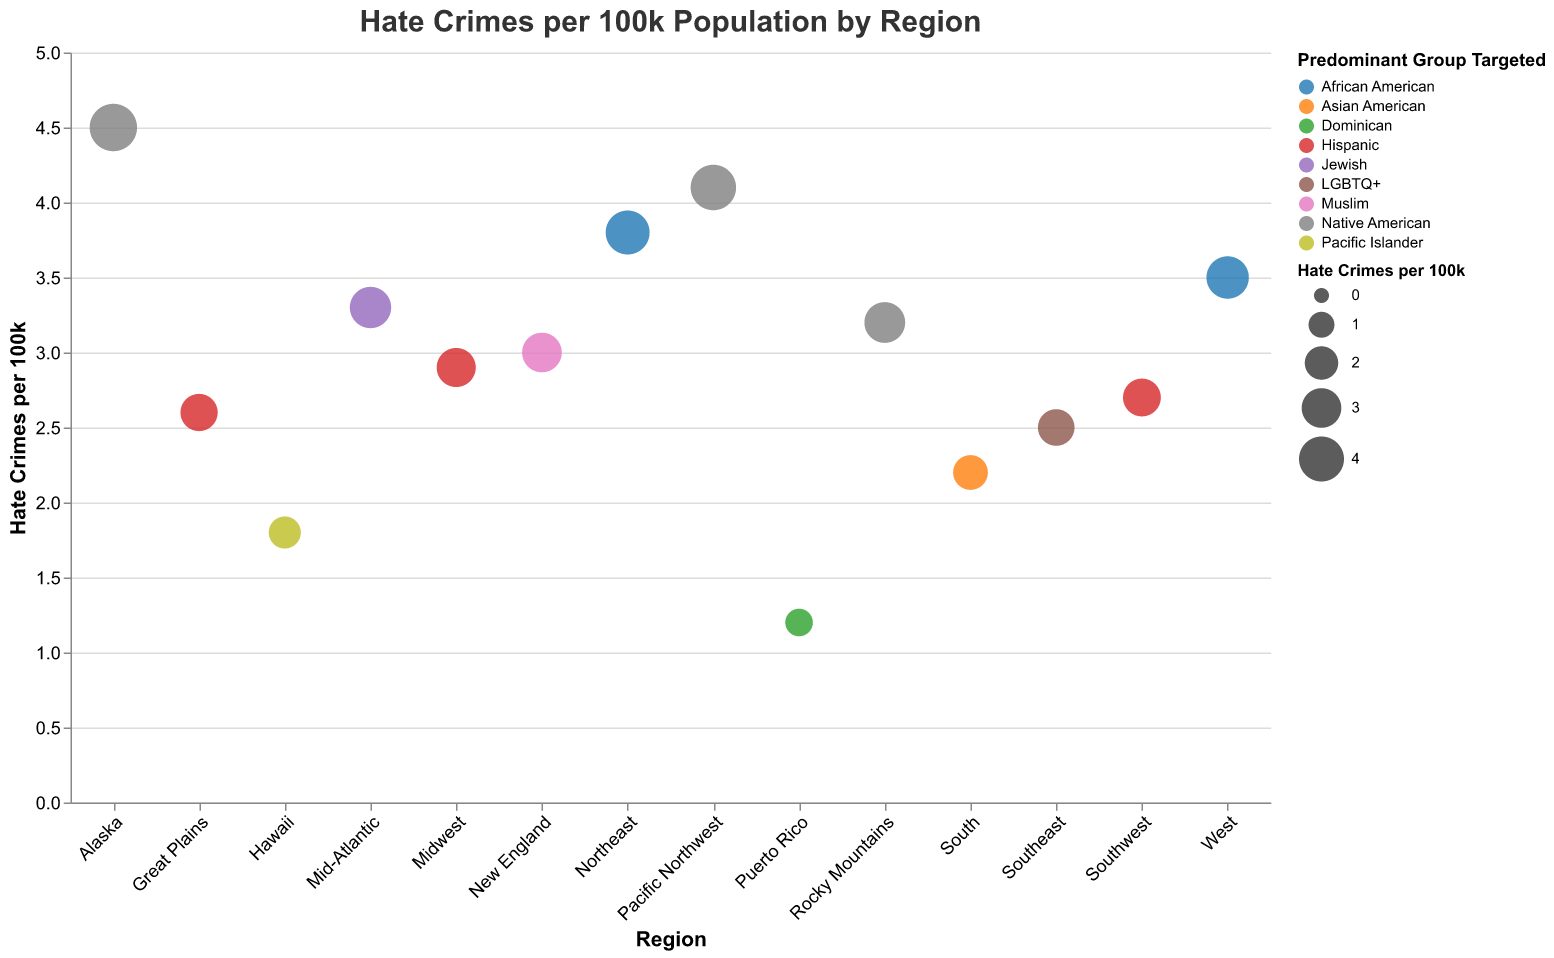Which region has the highest hate crime rate per 100k population? The figure shows the hate crimes per 100k population for each region. By comparing the values, Alaska has the highest hate crime rate, with 4.5 hate crimes per 100k population.
Answer: Alaska Which regions predominantly target Native Americans? By looking at the color and the legend indicating "Native American," we can identify the regions. The figure shows Pacific Northwest, Rocky Mountains, and Alaska primarily targeting Native Americans.
Answer: Pacific Northwest, Rocky Mountains, Alaska What's the difference in hate crime rates between the Northeast and the Southeast? The figure lists the hate crime rates for all regions. Subtract the Southeast rate from the Northeast rate: 3.8 (Northeast) - 2.5 (Southeast) = 1.3.
Answer: 1.3 Which region has the lowest hate crime rate per 100k population? The figure shows the hate crimes per 100k population for each region. By comparing the values, Puerto Rico has the lowest rate, with 1.2 hate crimes per 100k population.
Answer: Puerto Rico In which region is the hate crime rate for Muslims highest? The figure indicates each region and their corresponding hate crimes per 100k population and predominant race targeted. New England is the region where Muslims are primarily targeted with a rate of 3.0 per 100k.
Answer: New England How many regions have a hate crime rate of 3.0 or higher per 100k population? By counting the regions with a rate of 3.0 or higher on the figure: Northeast, West, Pacific Northwest, Mid-Atlantic, New England, Rocky Mountains, and Alaska, totaling 7 regions.
Answer: 7 Which regions predominantly target Hispanics, and what are their hate crime rates? The figure shows Hispanic-targeted regions and their hate crime rates: Midwest (2.9), Southwest (2.7), and Great Plains (2.6).
Answer: Midwest (2.9), Southwest (2.7), Great Plains (2.6) What is the average hate crime rate per 100k for regions predominantly targeting African Americans? The figure shows the hate crimes per 100k population for regions targeting African Americans: Northeast (3.8) and West (3.5). Calculate the average: (3.8 + 3.5) / 2 = 3.65.
Answer: 3.65 Which region has the highest hate crime rate against LGBTQ+ communities, and what is the rate? According to the figure, the Southeast region is where the LGBTQ+ community is predominantly targeted, with a hate crime rate of 2.5 per 100k population.
Answer: Southeast, 2.5 Is there any region with both a low hate crime rate and a specific target on a minority race? The figure indicates that Hawaii (1.8 per 100k), predominantly targeting Pacific Islanders, has a relatively low hate crime rate while focusing on a minority race.
Answer: Hawaii, 1.8 